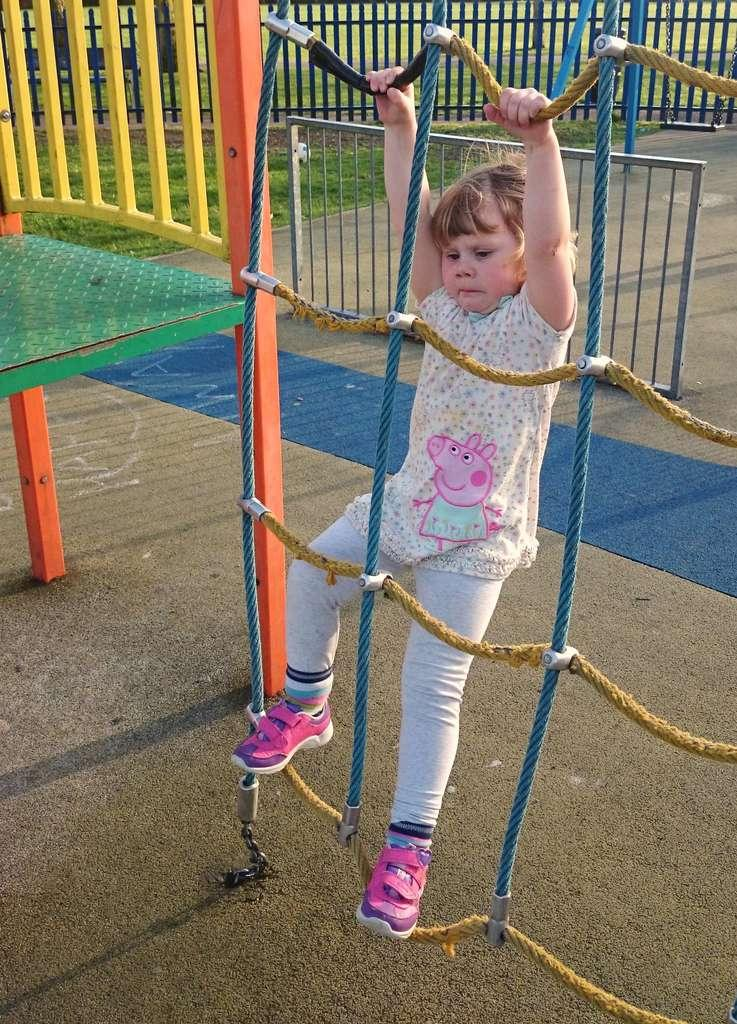What is the main subject of the image? There is a kid in the center of the image. What is the kid doing in the image? The kid is climbing a rope. What can be seen in the background of the image? There are fences, grass, a carpet, a table, and a few other objects in the background of the image. How many hands are visible in the image? There is no specific mention of hands in the image, so it is not possible to determine the number of hands visible. 